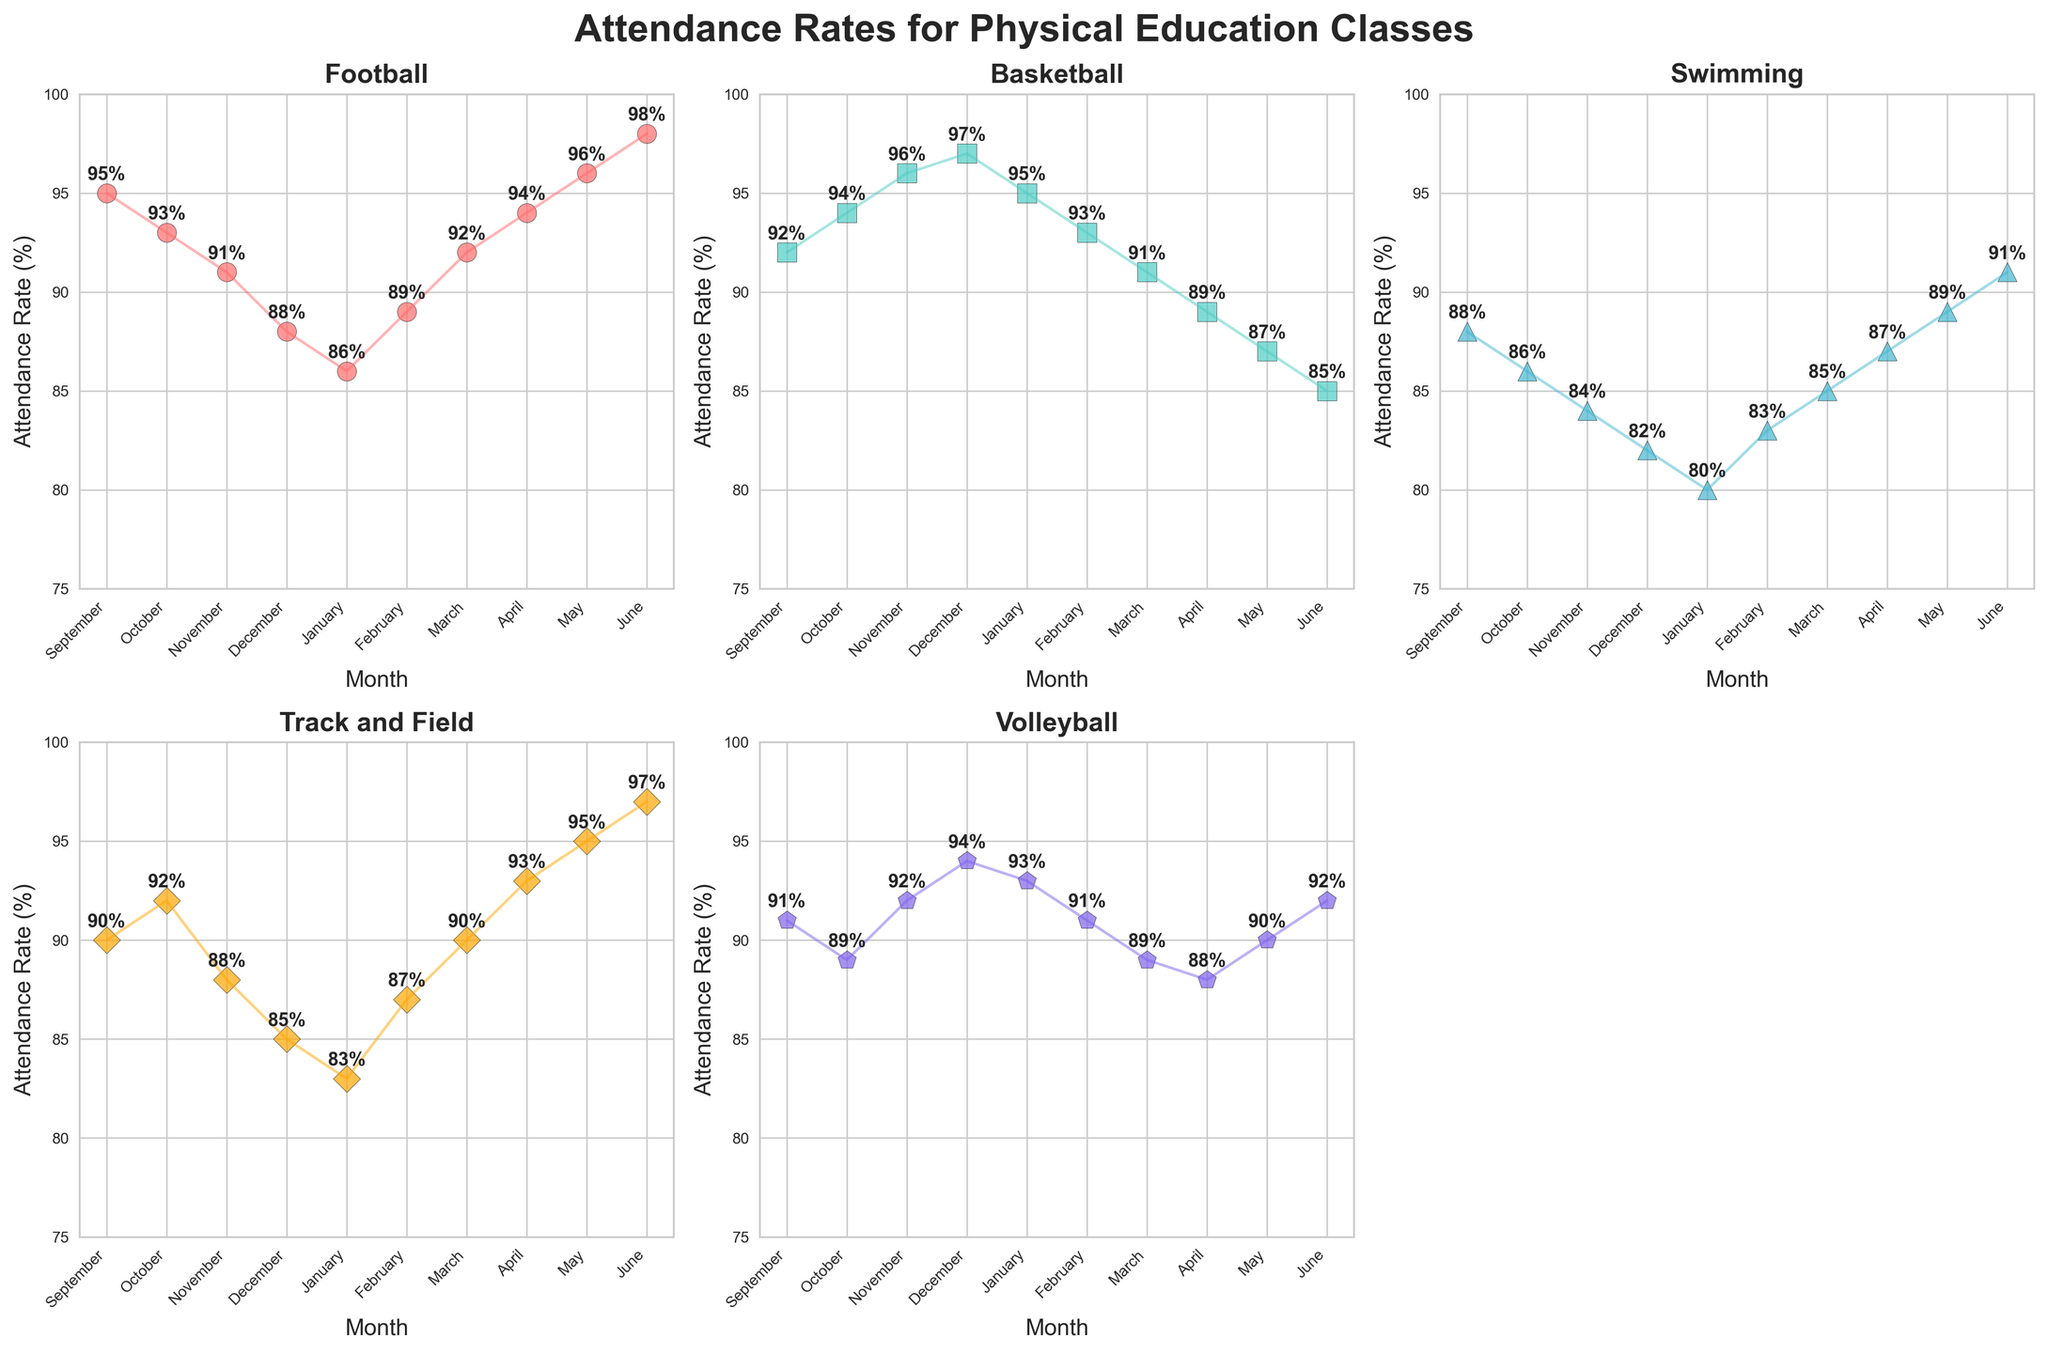Which physical education class has the highest attendance rate in June? Look at the plot for all physical education classes in June and identify the highest attendance rate. Football has an attendance rate of 98% in June, which is the highest among all.
Answer: Football What is the average attendance rate for Basketball from September to December? Add the attendance rates for Basketball from September to December (92 + 94 + 96 + 97) and divide by 4. The sum is 379 and the average is 379/4 which equals 94.75.
Answer: 94.75 Which month has the lowest attendance for Swimming? Check the scatter plot for Swimming and find the month where the data point is the lowest. The lowest attendance rate for Swimming is 80%, occurring in January.
Answer: January How does the attendance rate for Track and Field in February compare to May? Compare the attendance rates for Track and Field in February and May. The attendance rate is 87% in February and 95% in May, showing an increase from February to May.
Answer: Increases What is the difference in attendance rate for Volleyball between November and June? Subtract the attendance rate for Volleyball in November from the attendance rate in June. The difference is 92% - 94% = -2%.
Answer: -2% Which two months have the highest and lowest attendance in Football? Look at the scatter plot for Football and identify the highest and lowest data points. The highest attendance is in June (98%) and the lowest is in January (86%).
Answer: June and January How does the trend of attendance in Volleyball change from September to June? Examine the scatter plot for Volleyball from September to June and describe the general trend. The attendance rate starts at 91%, increases, and peaks at 94% in December, then slightly fluctuates and ends at 92% in June.
Answer: Fluctuating What is the sum of attendance rates for Swimming in the months of April and May? Add the attendance rates for Swimming in April and May (87 + 89), which equals 176.
Answer: 176 Between which months does Basketball see a decline in attendance rates? Check the Basketball scatter plot to see where the attendance rates decrease. The rate declines from December (97%) to March (91%) and continues until June (85%).
Answer: December to June 